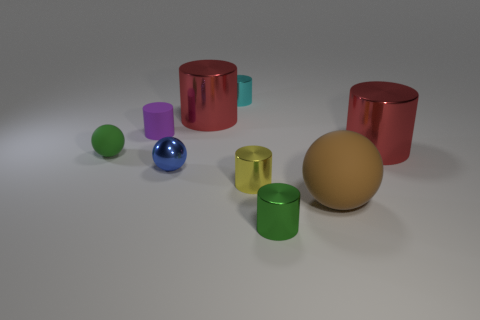Subtract all red cylinders. How many cylinders are left? 4 Subtract all balls. How many objects are left? 6 Add 1 tiny red blocks. How many objects exist? 10 Subtract all cyan metal cylinders. How many cylinders are left? 5 Subtract 3 cylinders. How many cylinders are left? 3 Subtract all gray cylinders. How many blue balls are left? 1 Subtract 1 yellow cylinders. How many objects are left? 8 Subtract all blue spheres. Subtract all yellow cylinders. How many spheres are left? 2 Subtract all yellow things. Subtract all green shiny cylinders. How many objects are left? 7 Add 3 cyan cylinders. How many cyan cylinders are left? 4 